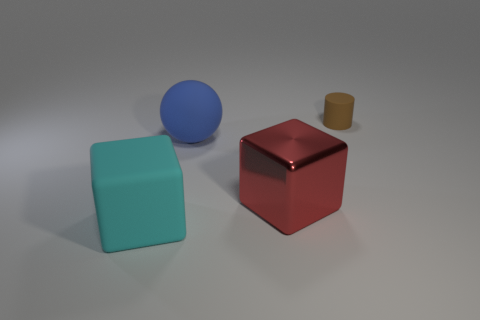Add 2 purple rubber cylinders. How many objects exist? 6 Subtract all spheres. How many objects are left? 3 Subtract 0 yellow blocks. How many objects are left? 4 Subtract all cyan rubber objects. Subtract all blue objects. How many objects are left? 2 Add 3 red metallic objects. How many red metallic objects are left? 4 Add 1 small brown objects. How many small brown objects exist? 2 